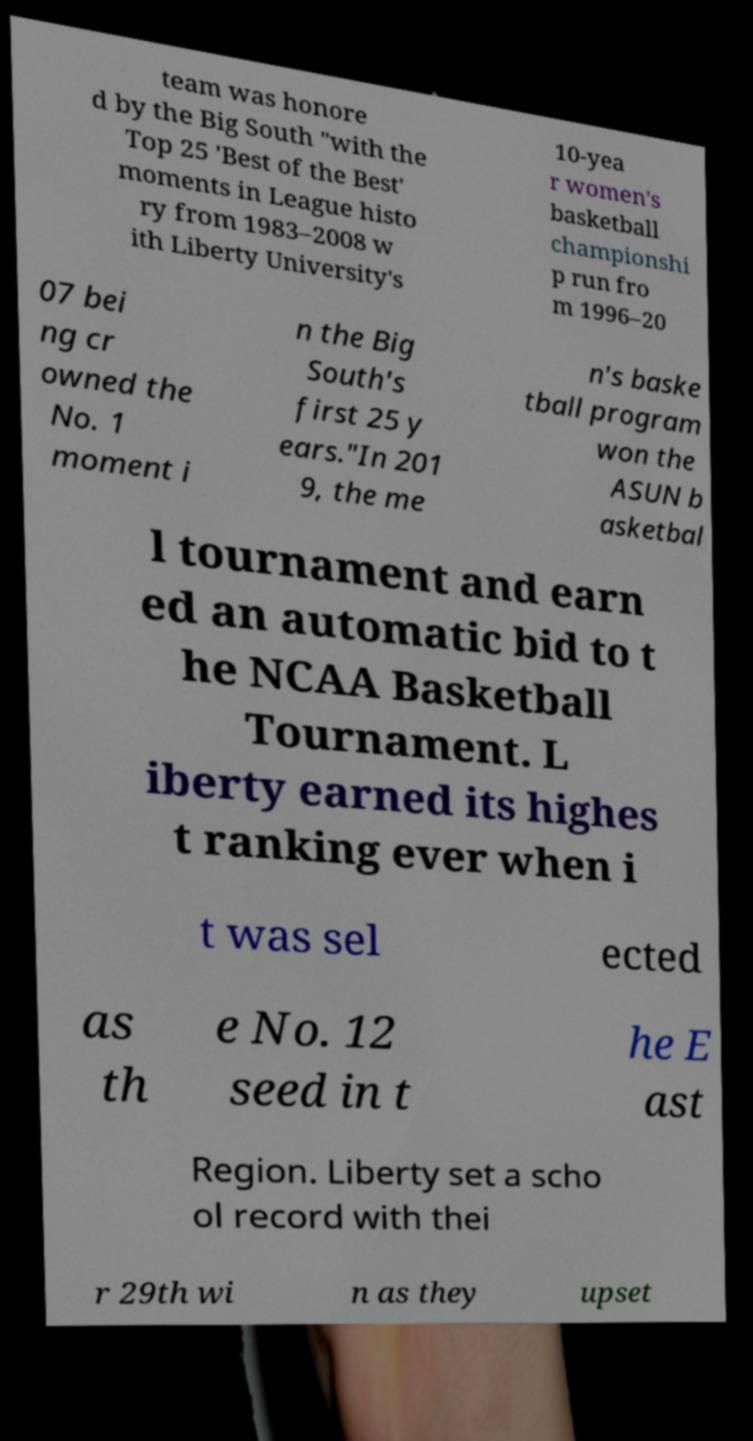Could you assist in decoding the text presented in this image and type it out clearly? team was honore d by the Big South "with the Top 25 'Best of the Best' moments in League histo ry from 1983–2008 w ith Liberty University's 10-yea r women's basketball championshi p run fro m 1996–20 07 bei ng cr owned the No. 1 moment i n the Big South's first 25 y ears."In 201 9, the me n's baske tball program won the ASUN b asketbal l tournament and earn ed an automatic bid to t he NCAA Basketball Tournament. L iberty earned its highes t ranking ever when i t was sel ected as th e No. 12 seed in t he E ast Region. Liberty set a scho ol record with thei r 29th wi n as they upset 